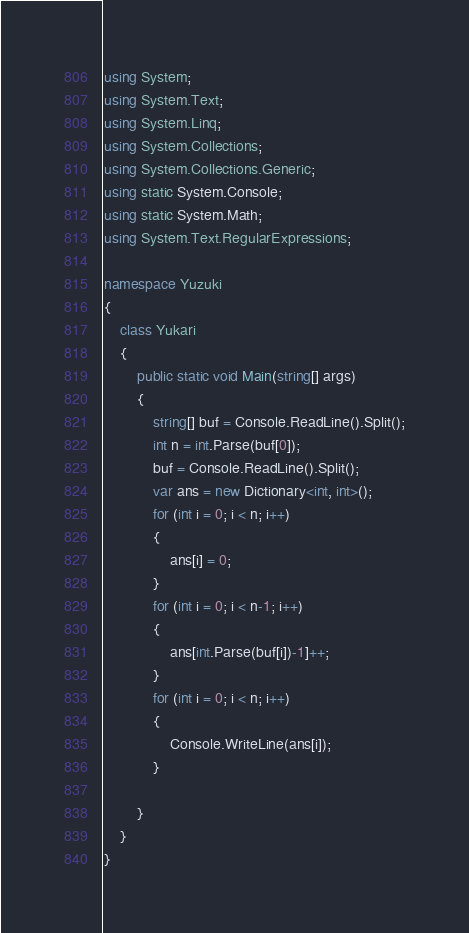<code> <loc_0><loc_0><loc_500><loc_500><_C#_>using System;
using System.Text;
using System.Linq;
using System.Collections;
using System.Collections.Generic;
using static System.Console;
using static System.Math;
using System.Text.RegularExpressions;

namespace Yuzuki
{
    class Yukari
    {
        public static void Main(string[] args)
        {
            string[] buf = Console.ReadLine().Split();
            int n = int.Parse(buf[0]);
            buf = Console.ReadLine().Split();
            var ans = new Dictionary<int, int>();
            for (int i = 0; i < n; i++)
            {
                ans[i] = 0;
            }
            for (int i = 0; i < n-1; i++)
            {
                ans[int.Parse(buf[i])-1]++;
            }
            for (int i = 0; i < n; i++)
            {
                Console.WriteLine(ans[i]);
            }
                
        }
    }
}</code> 